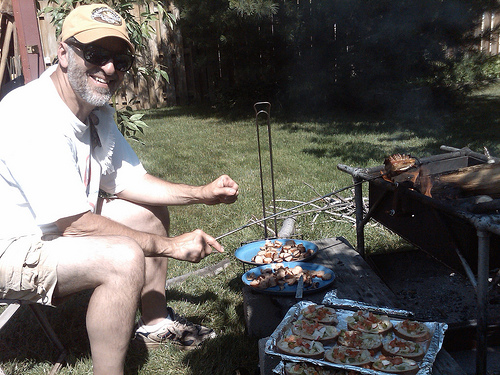<image>
Can you confirm if the fire is on the plate? No. The fire is not positioned on the plate. They may be near each other, but the fire is not supported by or resting on top of the plate. 